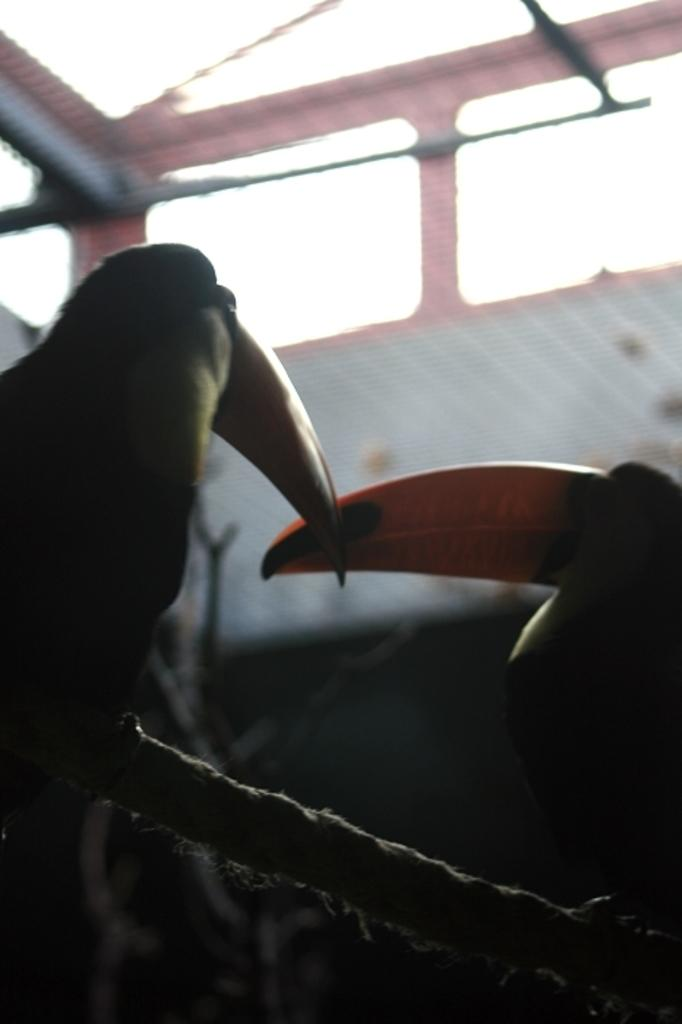What type of animals can be seen in the image? There are birds in the image. Where are the birds situated? The birds are sitting on stems. Can you describe the background of the image? The background of the image is blurred. What architectural feature is visible in the background? There are windows visible in the background of the image. What type of pancake can be seen in the image? There is no pancake present in the image. What is the tendency of the birds to fly away in the image? The image does not show the birds flying away, so it is not possible to determine their tendency to do so. 